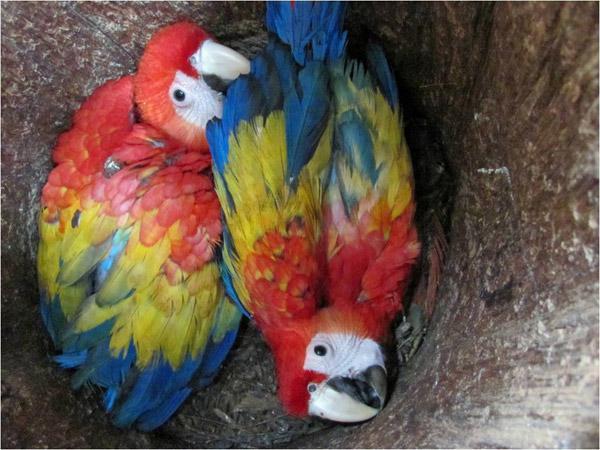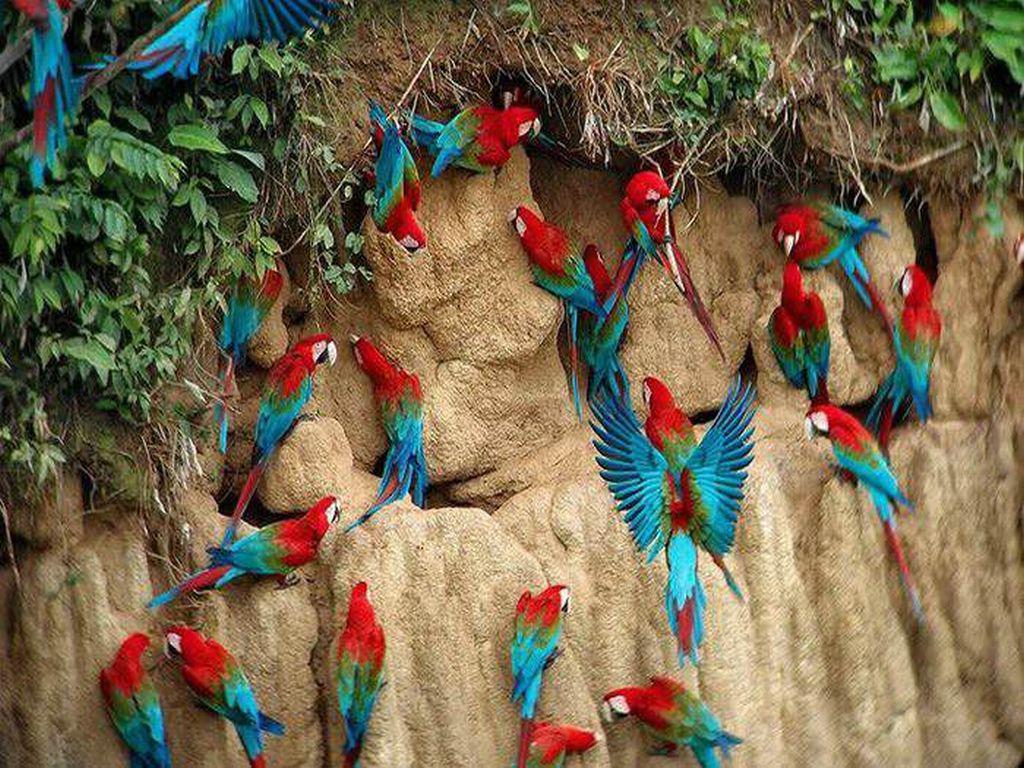The first image is the image on the left, the second image is the image on the right. Assess this claim about the two images: "The combined images show three colorful parrots, none with spread wings.". Correct or not? Answer yes or no. No. The first image is the image on the left, the second image is the image on the right. Given the left and right images, does the statement "There are three birds in total" hold true? Answer yes or no. No. 